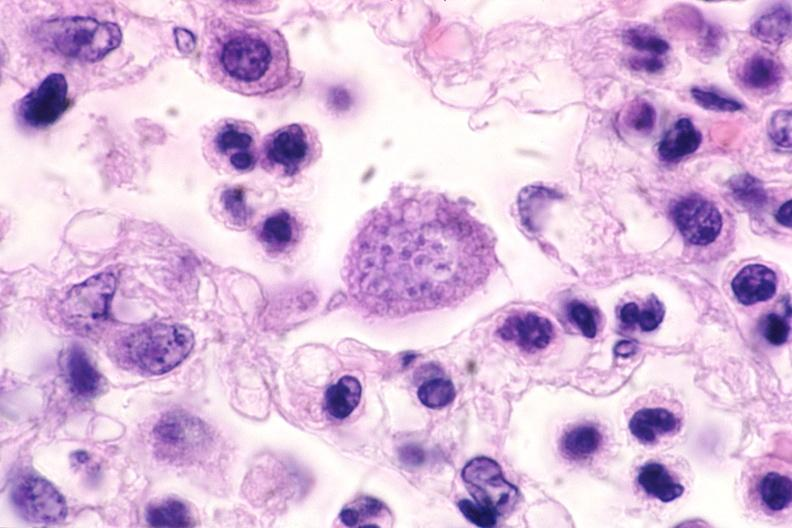what does this image show?
Answer the question using a single word or phrase. Touch impression from brain 